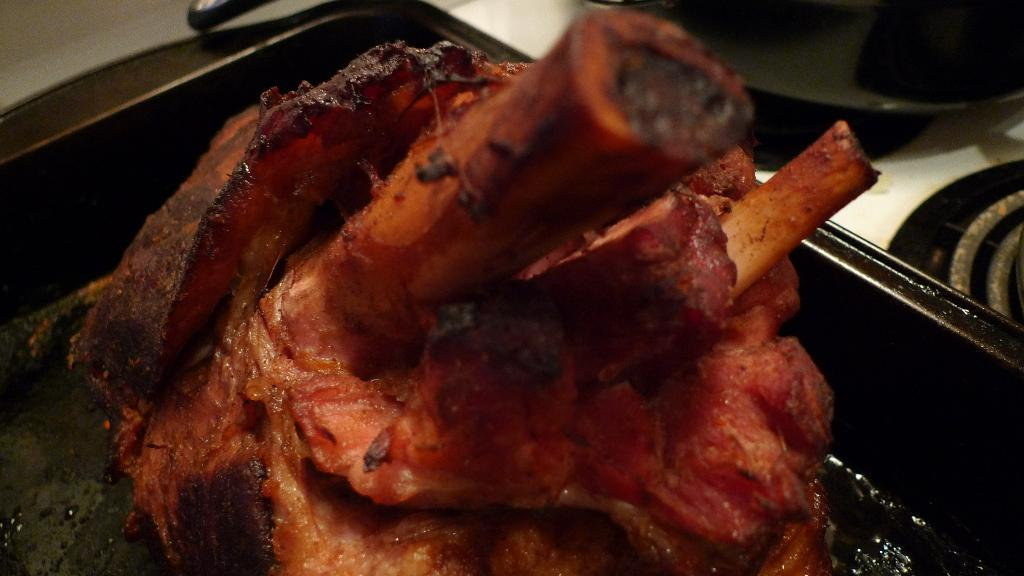What is located in the foreground of the image? There is meat in a tray in the foreground of the image. What can be seen in the background of the image? There are pans and a stove in the background of the image. What type of desk is visible in the image? There is no desk present in the image. Can you describe the wall in the image? There is no wall mentioned in the provided facts, so we cannot describe it. --- Facts: 1. There is a person sitting on a chair in the image. 2. The person is holding a book. 3. There is a table next to the chair. 4. There is a lamp on the table. Absurd Topics: bicycle, ocean, birdhouse Conversation: What is the person in the image doing? The person is sitting on a chair in the image. What is the person holding? The person is holding a book. What is located next to the chair? There is a table next to the chair. What is on the table? There is a lamp on the table. Reasoning: Let's think step by step in order to produce the conversation. We start by identifying the main subject in the image, which is the person sitting on a chair. Then, we expand the conversation to include other items that are also visible, such as the book, table, and lamp. Each question is designed to elicit a specific detail about the image that is known from the provided facts. Absurd Question/Answer: Can you describe the birdhouse in the image? There is no birdhouse present in the image. What type of bicycle is visible in the image? There is no bicycle present in the image. 